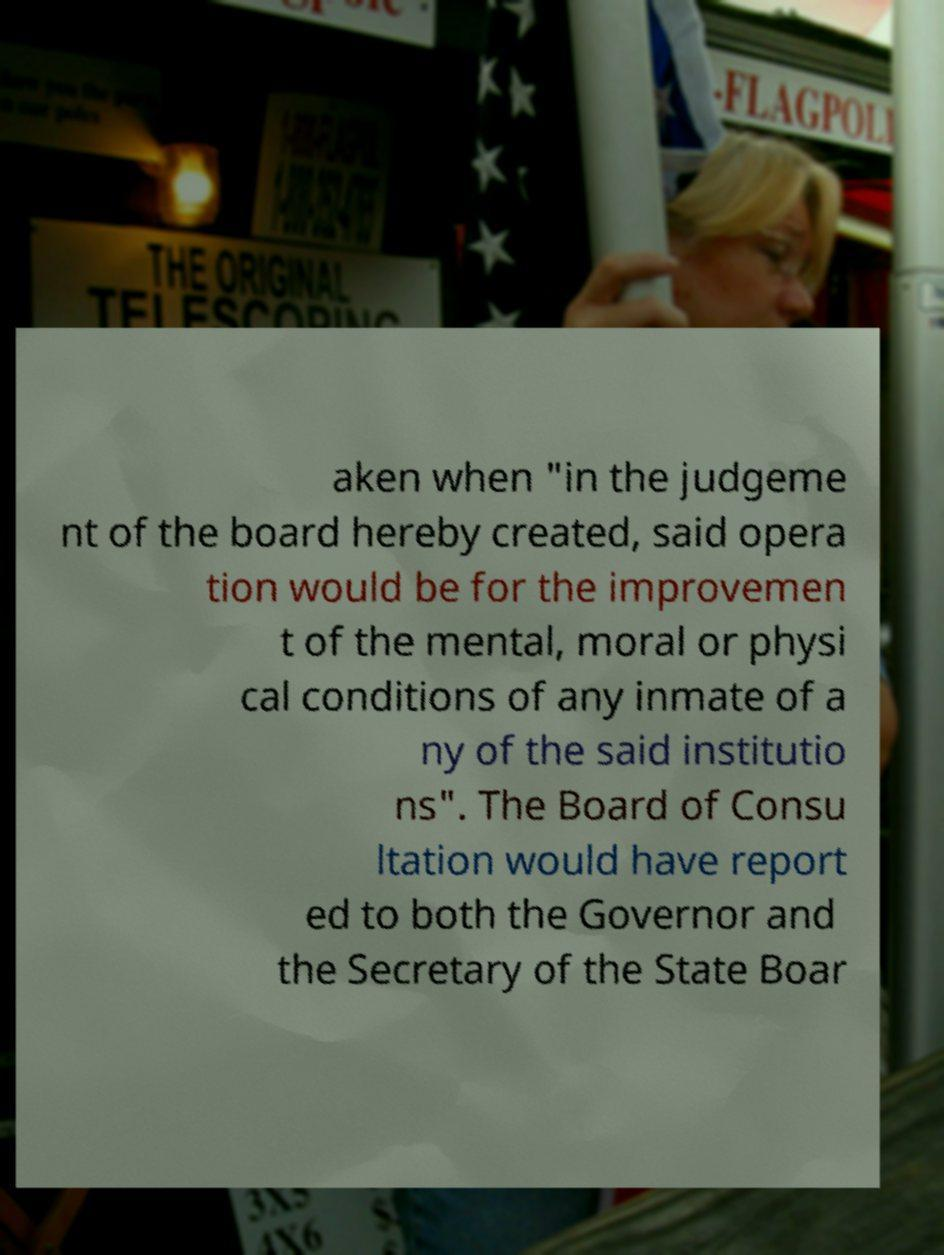I need the written content from this picture converted into text. Can you do that? aken when "in the judgeme nt of the board hereby created, said opera tion would be for the improvemen t of the mental, moral or physi cal conditions of any inmate of a ny of the said institutio ns". The Board of Consu ltation would have report ed to both the Governor and the Secretary of the State Boar 